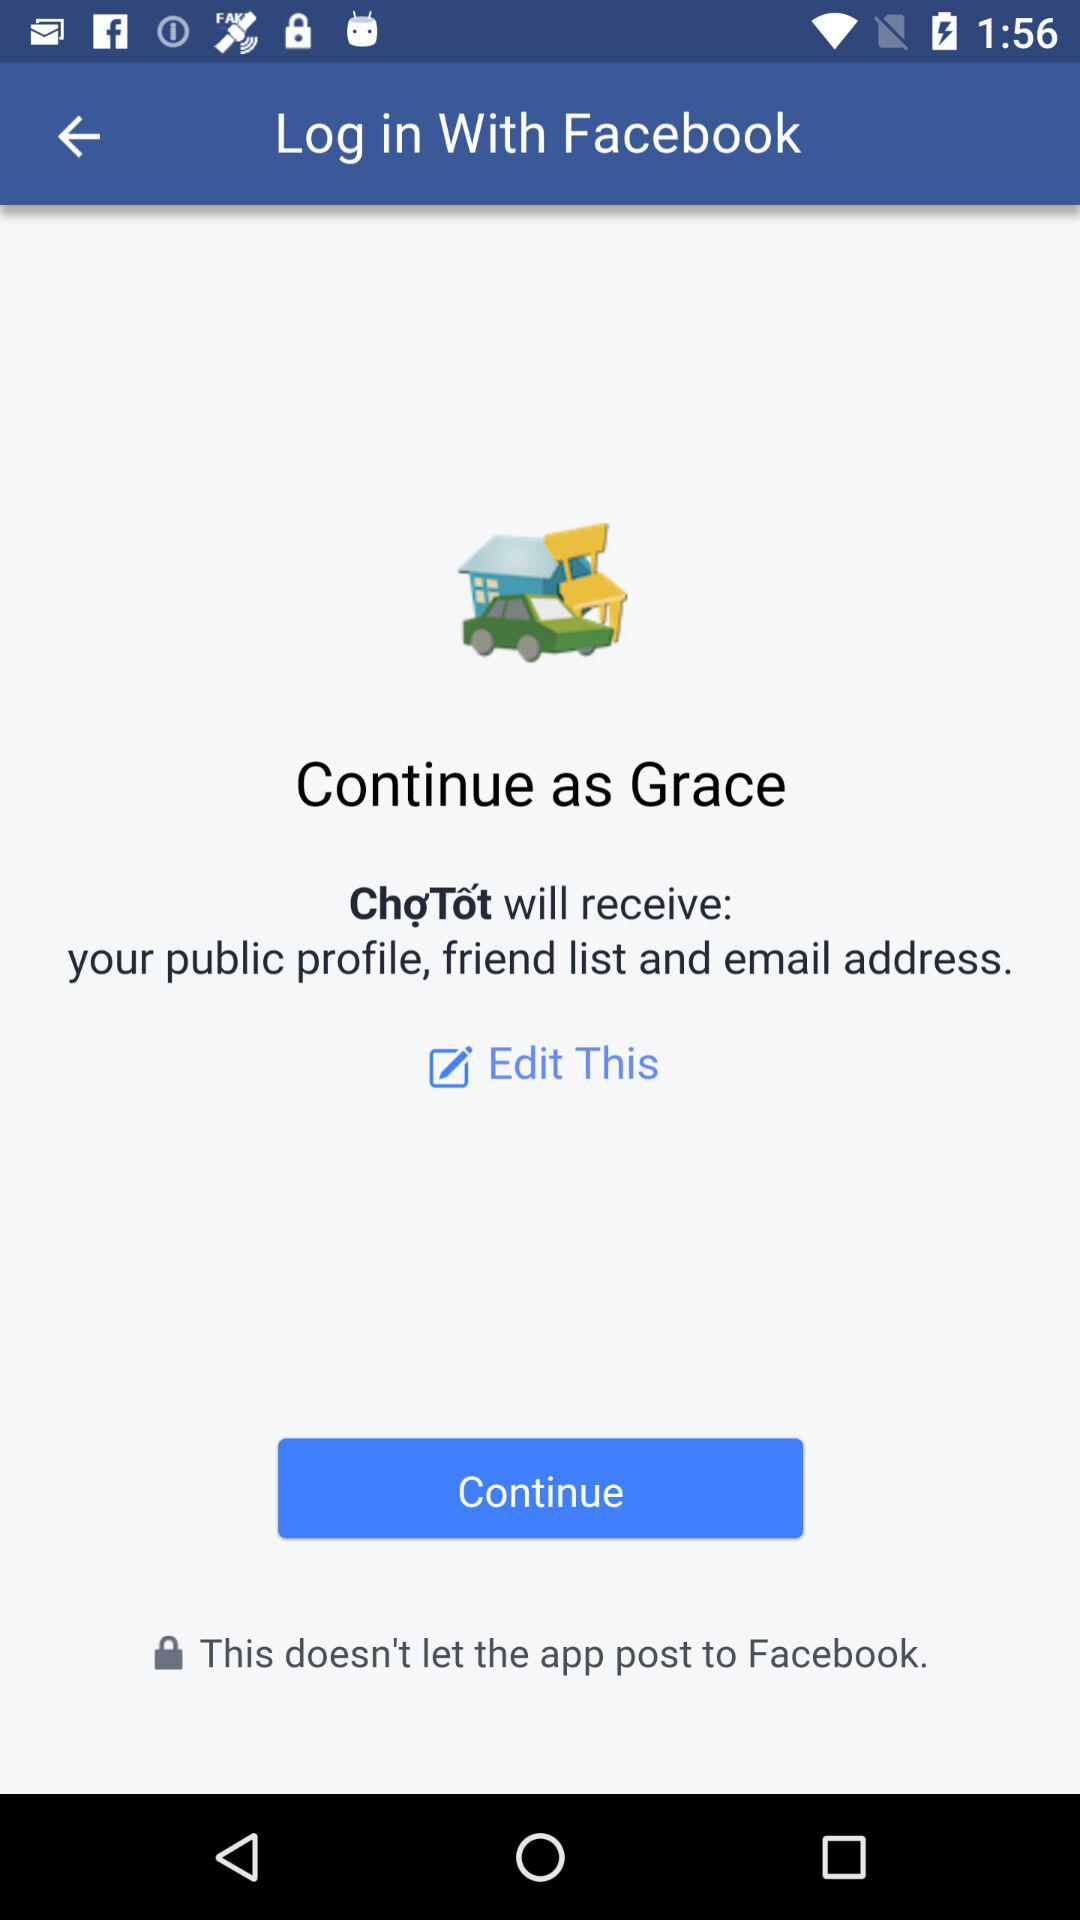What application is asking for permission? The application asking for permission is "ChợTốt". 